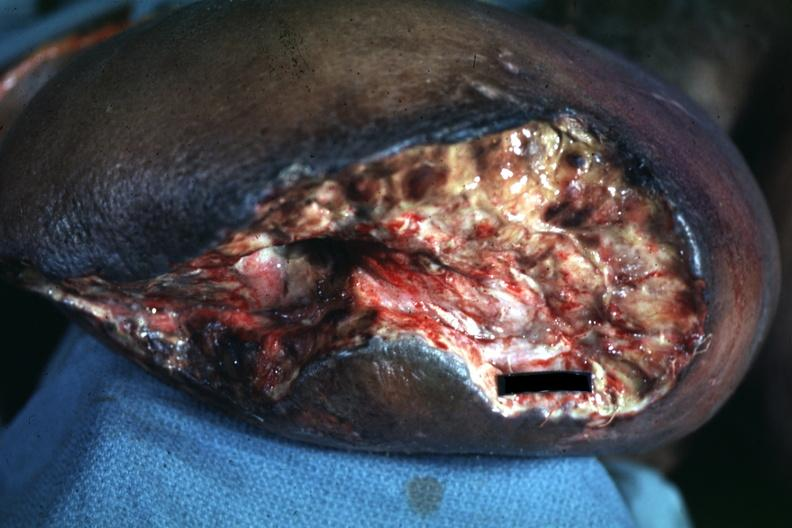what is present?
Answer the question using a single word or phrase. Amputation stump infected 